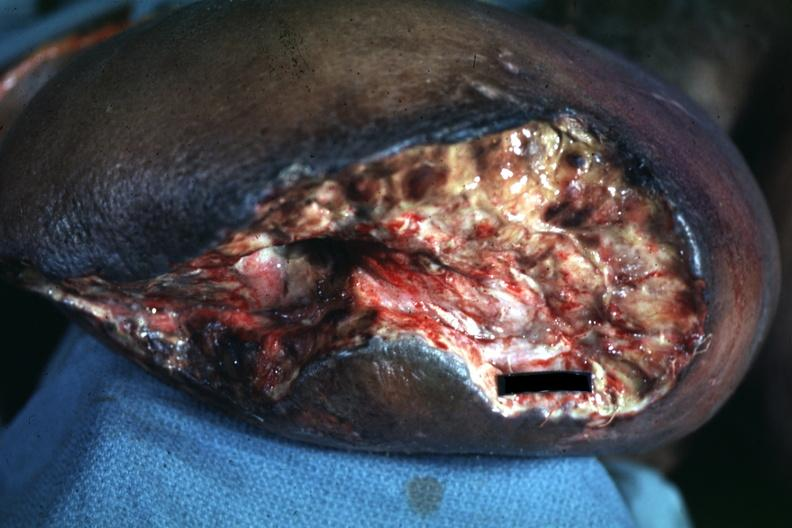what is present?
Answer the question using a single word or phrase. Amputation stump infected 